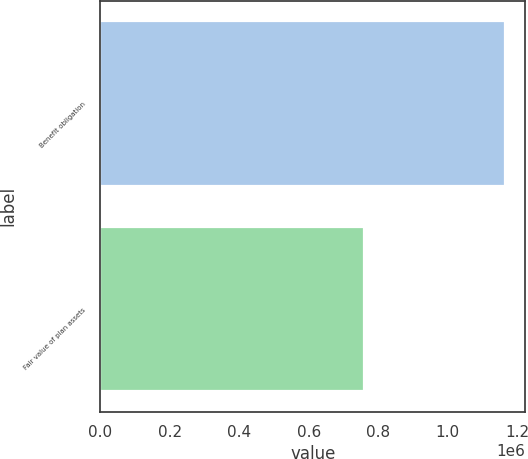Convert chart. <chart><loc_0><loc_0><loc_500><loc_500><bar_chart><fcel>Benefit obligation<fcel>Fair value of plan assets<nl><fcel>1.16452e+06<fcel>760155<nl></chart> 